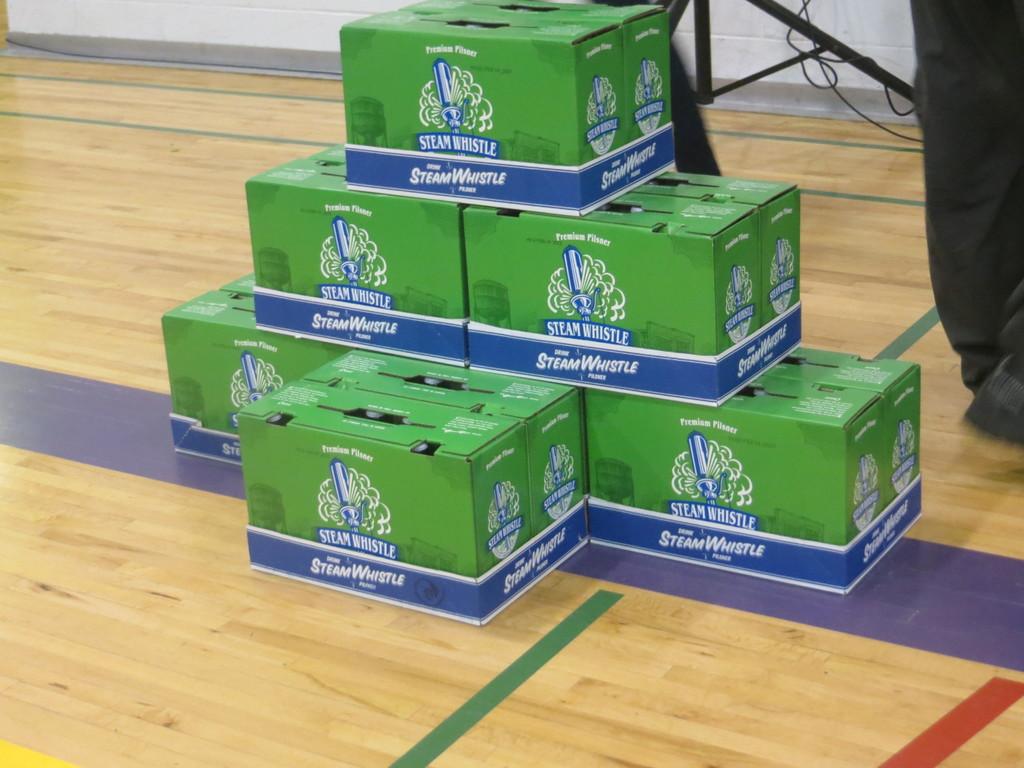What is in boxes?
Offer a terse response. Steam whistle. What brand is that?
Provide a succinct answer. Steam whistle. 